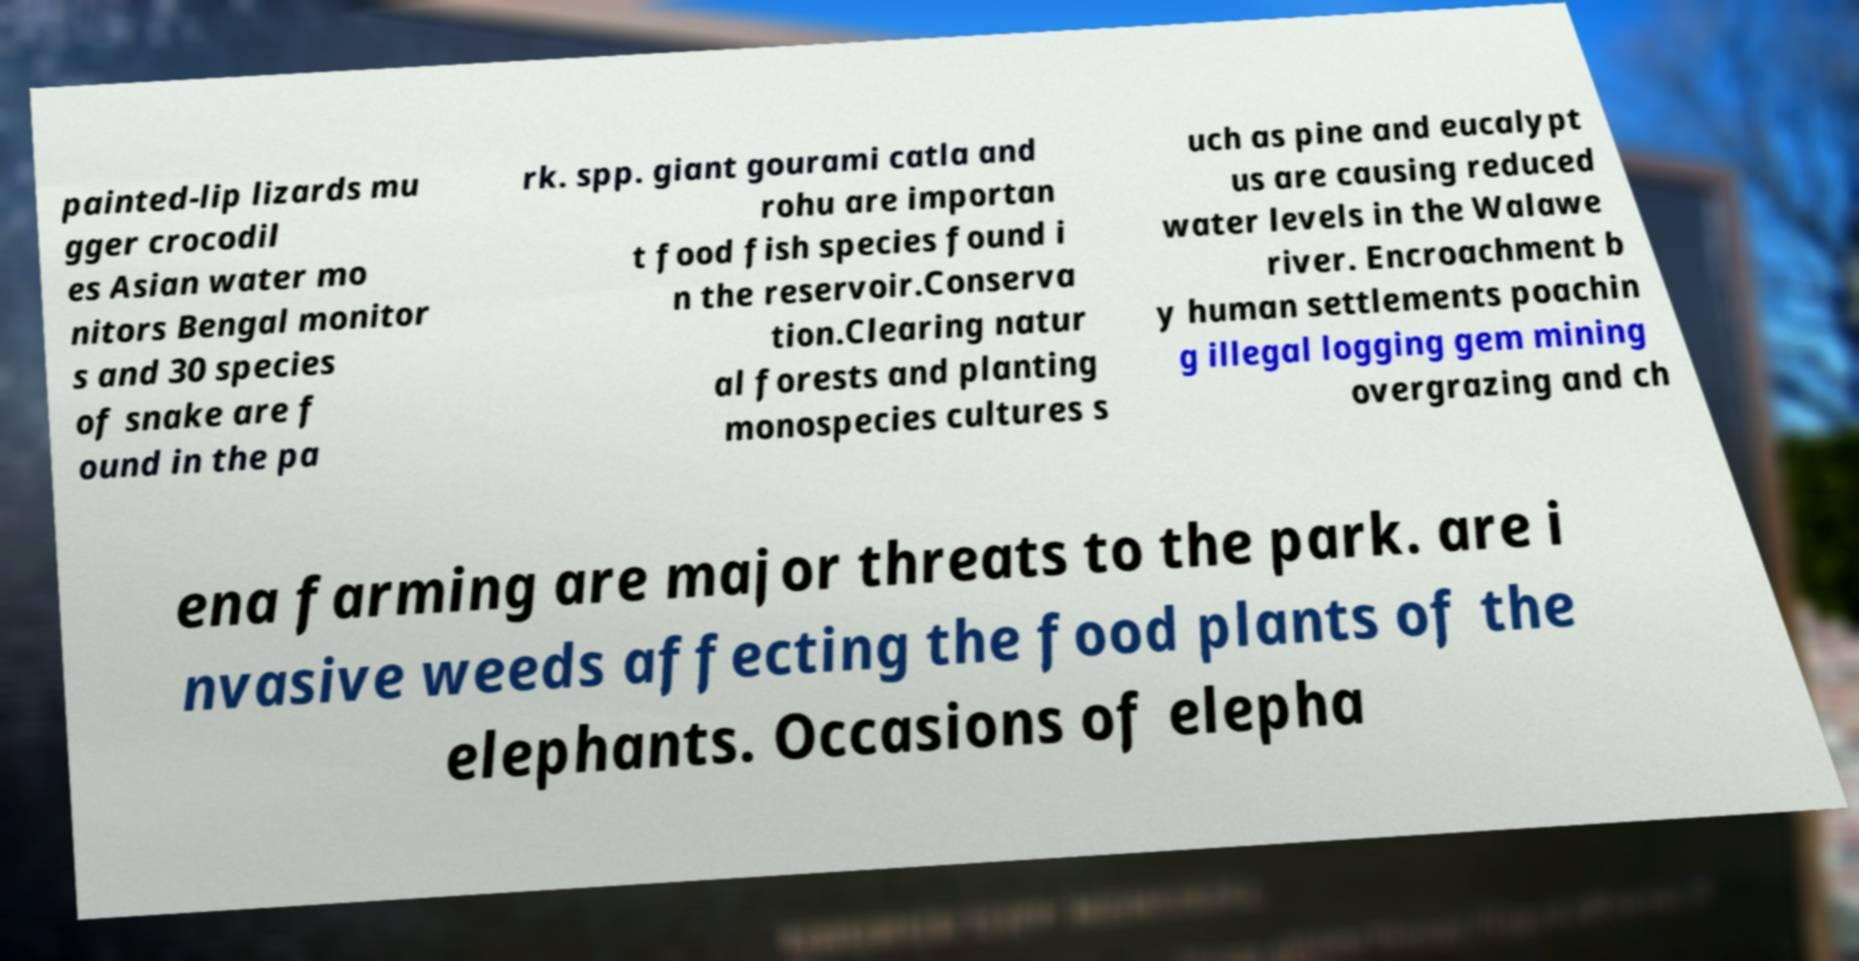Could you extract and type out the text from this image? painted-lip lizards mu gger crocodil es Asian water mo nitors Bengal monitor s and 30 species of snake are f ound in the pa rk. spp. giant gourami catla and rohu are importan t food fish species found i n the reservoir.Conserva tion.Clearing natur al forests and planting monospecies cultures s uch as pine and eucalypt us are causing reduced water levels in the Walawe river. Encroachment b y human settlements poachin g illegal logging gem mining overgrazing and ch ena farming are major threats to the park. are i nvasive weeds affecting the food plants of the elephants. Occasions of elepha 